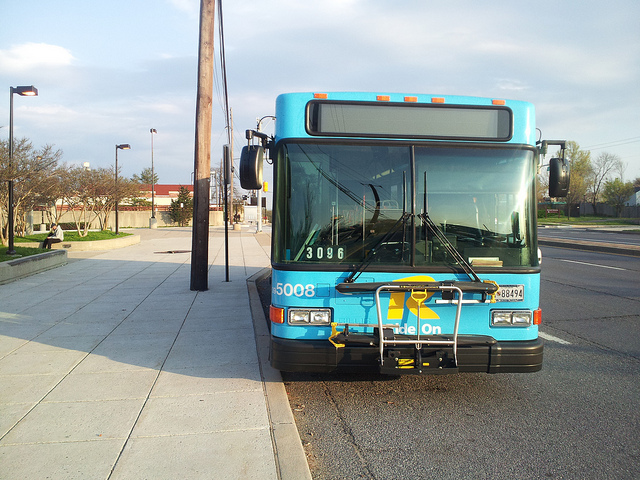Please transcribe the text in this image. 3096 5008 On 